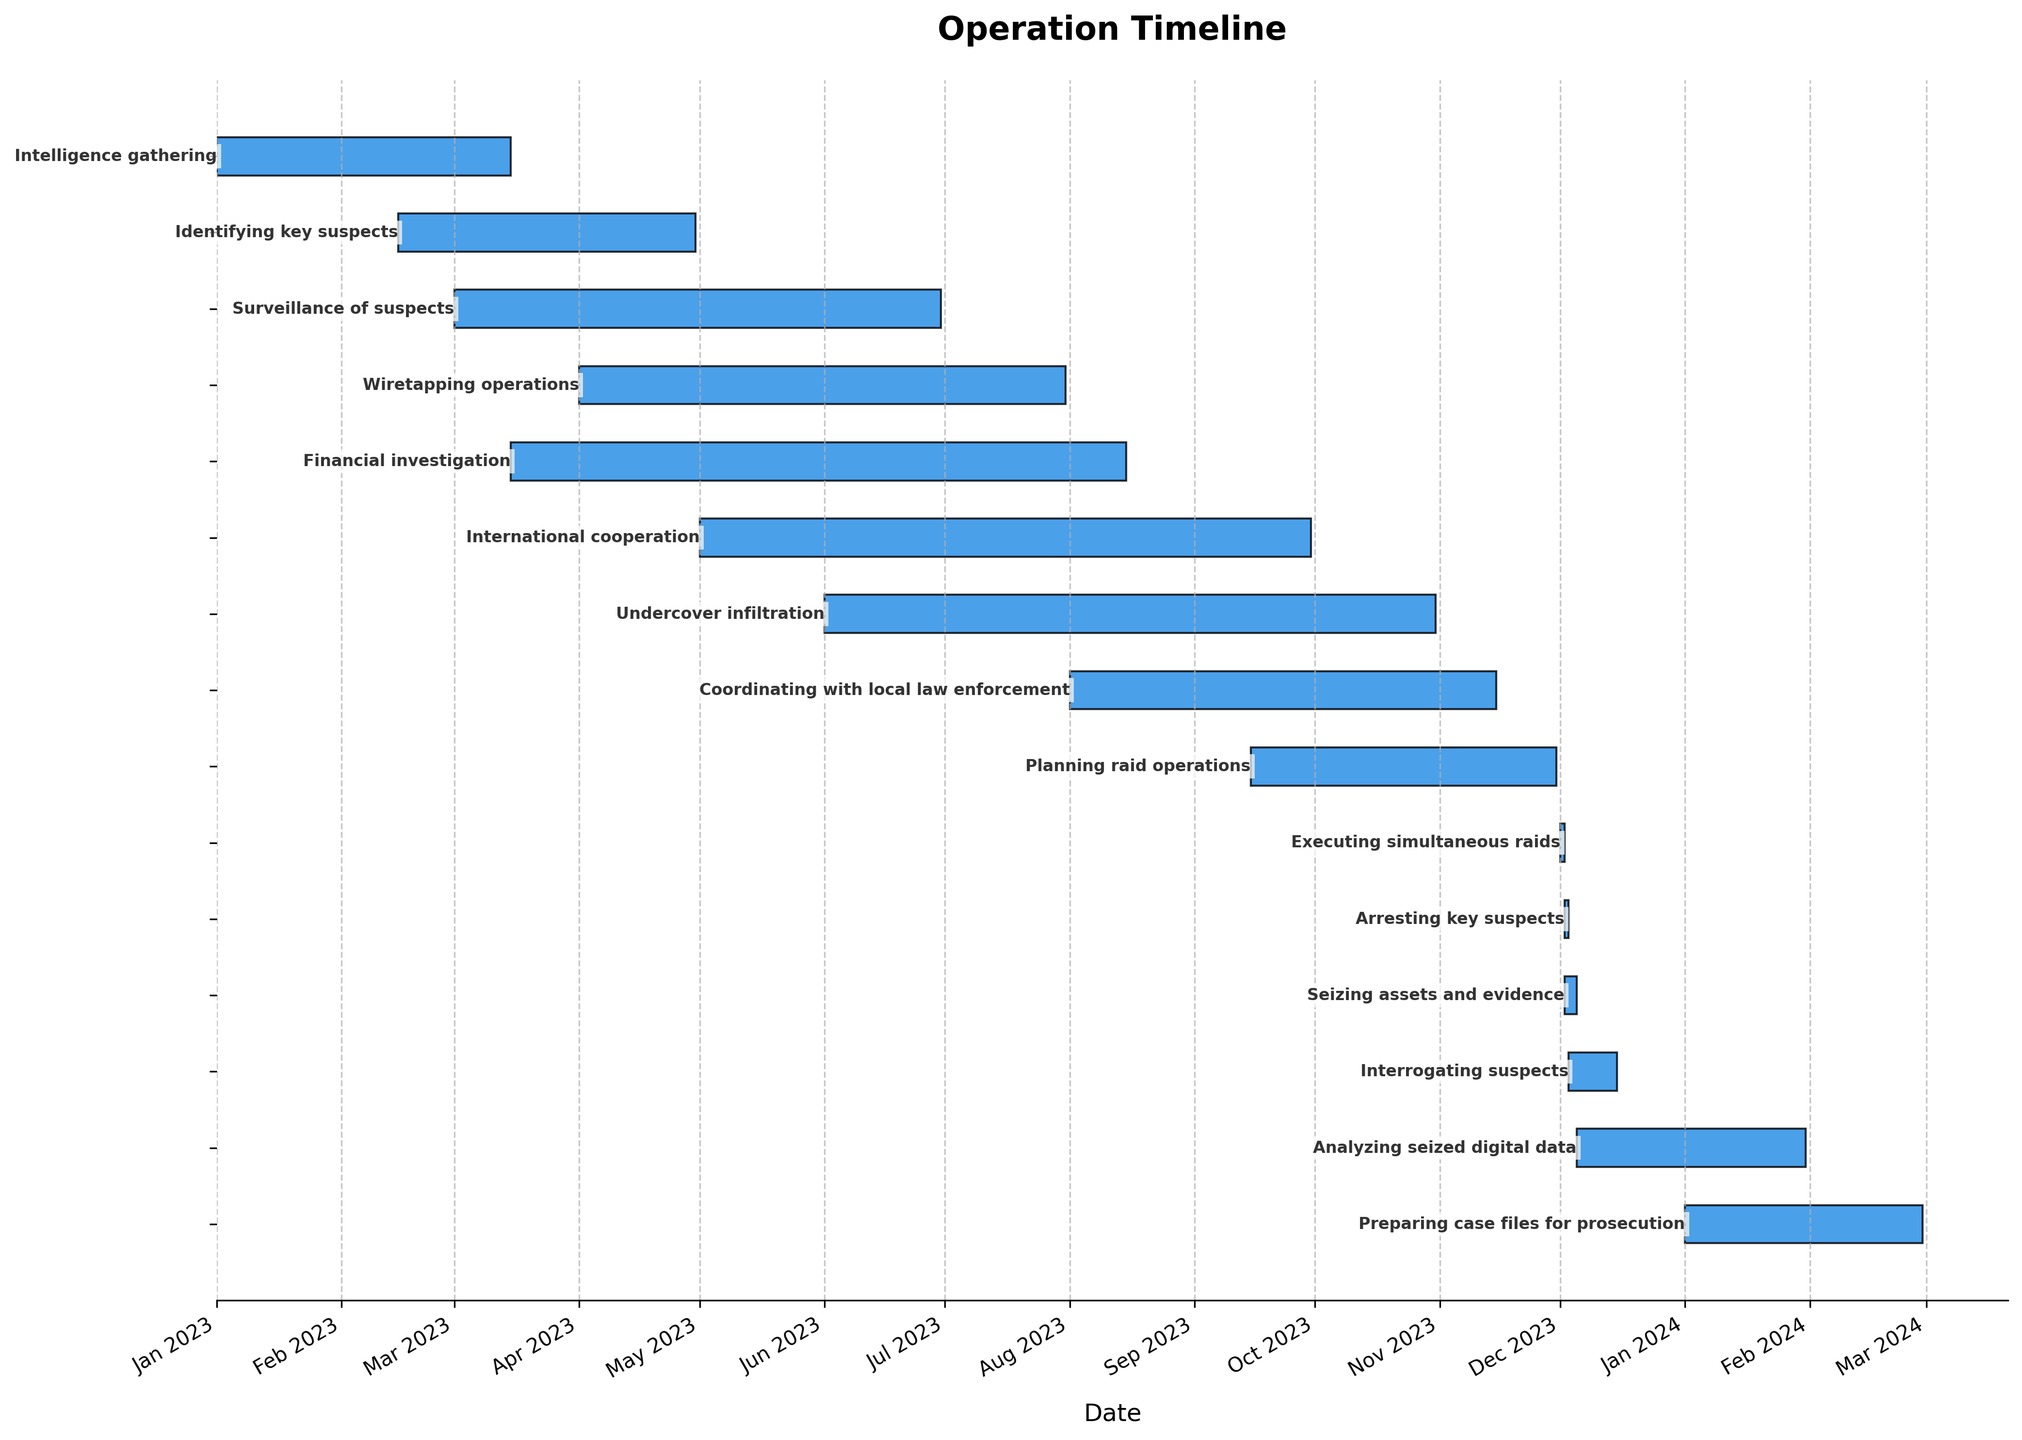what is the title of the figure? The title is located at the top of the figure and typically provides a brief description of what the figure represents.
Answer: Operation Timeline How many phases does the operation have? Count the number of bars on the Gantt chart, as each bar represents a phase of the operation.
Answer: 15 Which phase starts the earliest? Identify the bar that starts the furthest to the left on the timeline. This represents the earliest-starting phase.
Answer: Intelligence gathering Which phase has the shortest duration? Look for the bar that is the shortest in length. Compare it to the other bars to confirm that it has the shortest span between its start and end dates.
Answer: Executing simultaneous raids During which months does the financial investigation phase run? Observe the position and length of the financial investigation bar on the timeline. Note the months that the bar spans across.
Answer: March to August 2023 How long does the surveillance of suspects phase last? Measure the length of the bar representing the surveillance phase. The difference between the end date and start date will give the duration.
Answer: 4 months How many phases overlap with the planning raid operations phase? Identify the bar representing the planning raid operations phase. Count how many other bars overlap with it, indicating concurrent phases.
Answer: 4 Which phase lasts longer: wiretapping operations or financial investigation? Compare the lengths of the bars representing wiretapping operations and financial investigation. The longer bar represents the longer phase.
Answer: Financial investigation Which two phases end at the same date? Find bars that terminate at the same point on the timeline. These correspond to phases ending on the same date.
Answer: Coordinating with local law enforcement, Planning raid operations Which phase involves international cooperation, and what is its duration? Locate the bar labeled "International cooperation." Measure the length of this bar to determine its duration from start to end date.
Answer: 5 months 